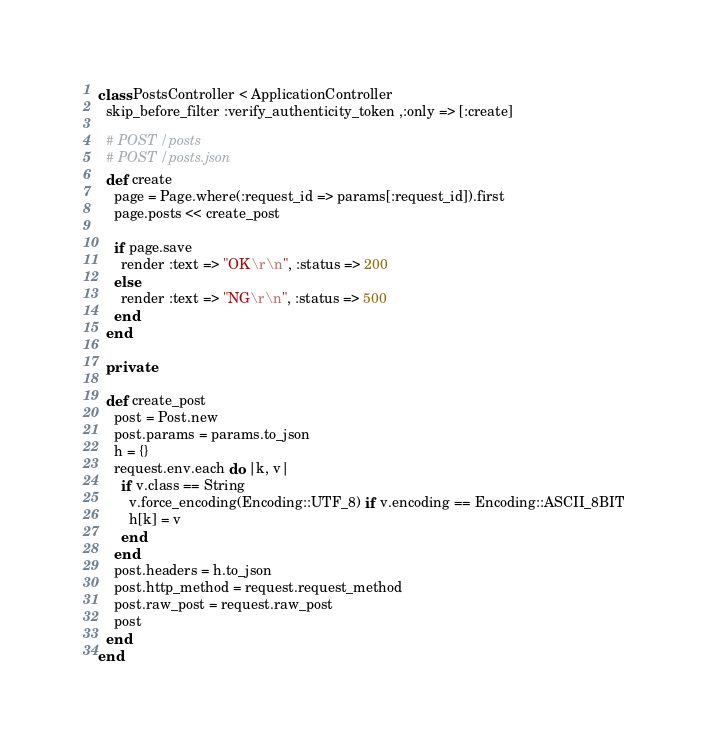Convert code to text. <code><loc_0><loc_0><loc_500><loc_500><_Ruby_>class PostsController < ApplicationController
  skip_before_filter :verify_authenticity_token ,:only => [:create]

  # POST /posts
  # POST /posts.json
  def create
    page = Page.where(:request_id => params[:request_id]).first
    page.posts << create_post

    if page.save
      render :text => "OK\r\n", :status => 200
    else
      render :text => "NG\r\n", :status => 500
    end
  end

  private

  def create_post
    post = Post.new
    post.params = params.to_json
    h = {}
    request.env.each do |k, v|
      if v.class == String
        v.force_encoding(Encoding::UTF_8) if v.encoding == Encoding::ASCII_8BIT
        h[k] = v
      end
    end
    post.headers = h.to_json
    post.http_method = request.request_method
    post.raw_post = request.raw_post
    post
  end
end
</code> 